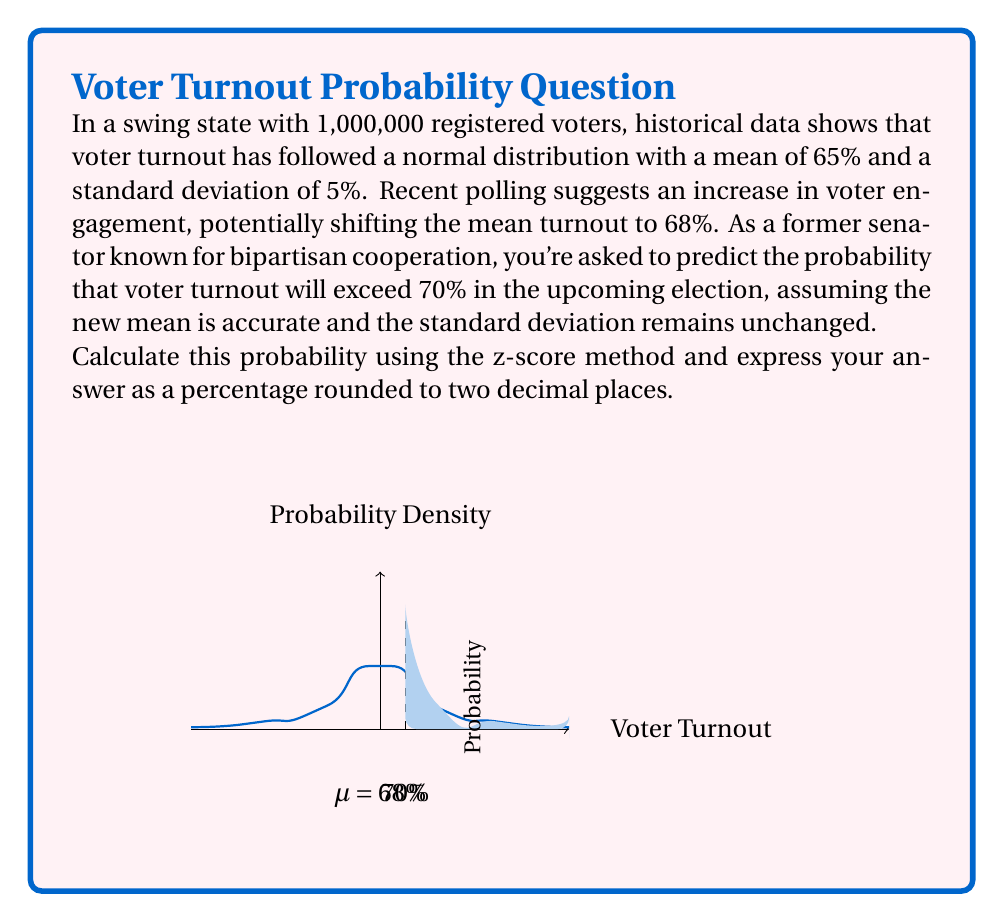Provide a solution to this math problem. To solve this problem, we'll use the z-score method to calculate the probability. Here's a step-by-step explanation:

1) First, we need to calculate the z-score for 70% turnout given the new mean (μ) of 68% and standard deviation (σ) of 5%.

   The z-score formula is: $z = \frac{x - \mu}{\sigma}$

   Where x is the value we're interested in (70%), μ is the mean (68%), and σ is the standard deviation (5%).

2) Plugging in the values:

   $z = \frac{70 - 68}{5} = \frac{2}{5} = 0.4$

3) Now that we have the z-score, we need to find the area under the standard normal curve to the right of this z-score. This represents the probability of a turnout greater than 70%.

4) We can use a standard normal table or a statistical calculator for this. The area to the right of z = 0.4 is approximately 0.3446.

5) To convert this to a percentage, we multiply by 100:

   0.3446 * 100 = 34.46%

6) Rounding to two decimal places, we get 34.46%.

This means there's a 34.46% chance that voter turnout will exceed 70% in the upcoming election, given the assumptions in the question.
Answer: 34.46% 